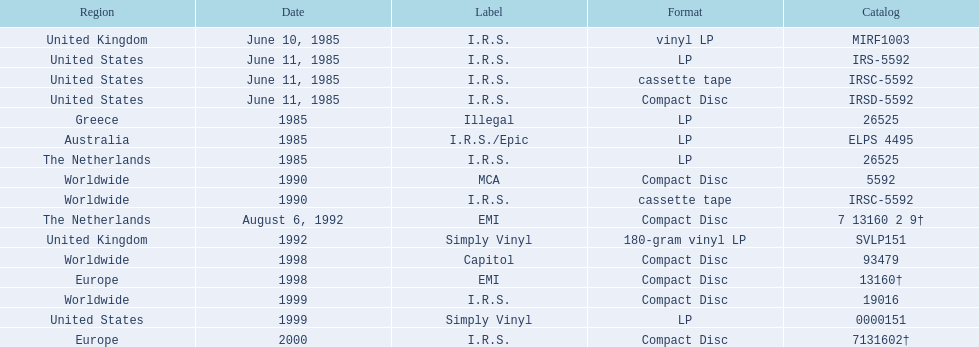In which areas was the "fables of the reconstruction" album launched? United Kingdom, United States, United States, United States, Greece, Australia, The Netherlands, Worldwide, Worldwide, The Netherlands, United Kingdom, Worldwide, Europe, Worldwide, United States, Europe. Could you parse the entire table as a dict? {'header': ['Region', 'Date', 'Label', 'Format', 'Catalog'], 'rows': [['United Kingdom', 'June 10, 1985', 'I.R.S.', 'vinyl LP', 'MIRF1003'], ['United States', 'June 11, 1985', 'I.R.S.', 'LP', 'IRS-5592'], ['United States', 'June 11, 1985', 'I.R.S.', 'cassette tape', 'IRSC-5592'], ['United States', 'June 11, 1985', 'I.R.S.', 'Compact Disc', 'IRSD-5592'], ['Greece', '1985', 'Illegal', 'LP', '26525'], ['Australia', '1985', 'I.R.S./Epic', 'LP', 'ELPS 4495'], ['The Netherlands', '1985', 'I.R.S.', 'LP', '26525'], ['Worldwide', '1990', 'MCA', 'Compact Disc', '5592'], ['Worldwide', '1990', 'I.R.S.', 'cassette tape', 'IRSC-5592'], ['The Netherlands', 'August 6, 1992', 'EMI', 'Compact Disc', '7 13160 2 9†'], ['United Kingdom', '1992', 'Simply Vinyl', '180-gram vinyl LP', 'SVLP151'], ['Worldwide', '1998', 'Capitol', 'Compact Disc', '93479'], ['Europe', '1998', 'EMI', 'Compact Disc', '13160†'], ['Worldwide', '1999', 'I.R.S.', 'Compact Disc', '19016'], ['United States', '1999', 'Simply Vinyl', 'LP', '0000151'], ['Europe', '2000', 'I.R.S.', 'Compact Disc', '7131602†']]} And what were the launch dates for those areas? June 10, 1985, June 11, 1985, June 11, 1985, June 11, 1985, 1985, 1985, 1985, 1990, 1990, August 6, 1992, 1992, 1998, 1998, 1999, 1999, 2000. And which area was mentioned after greece in 1985? Australia. 